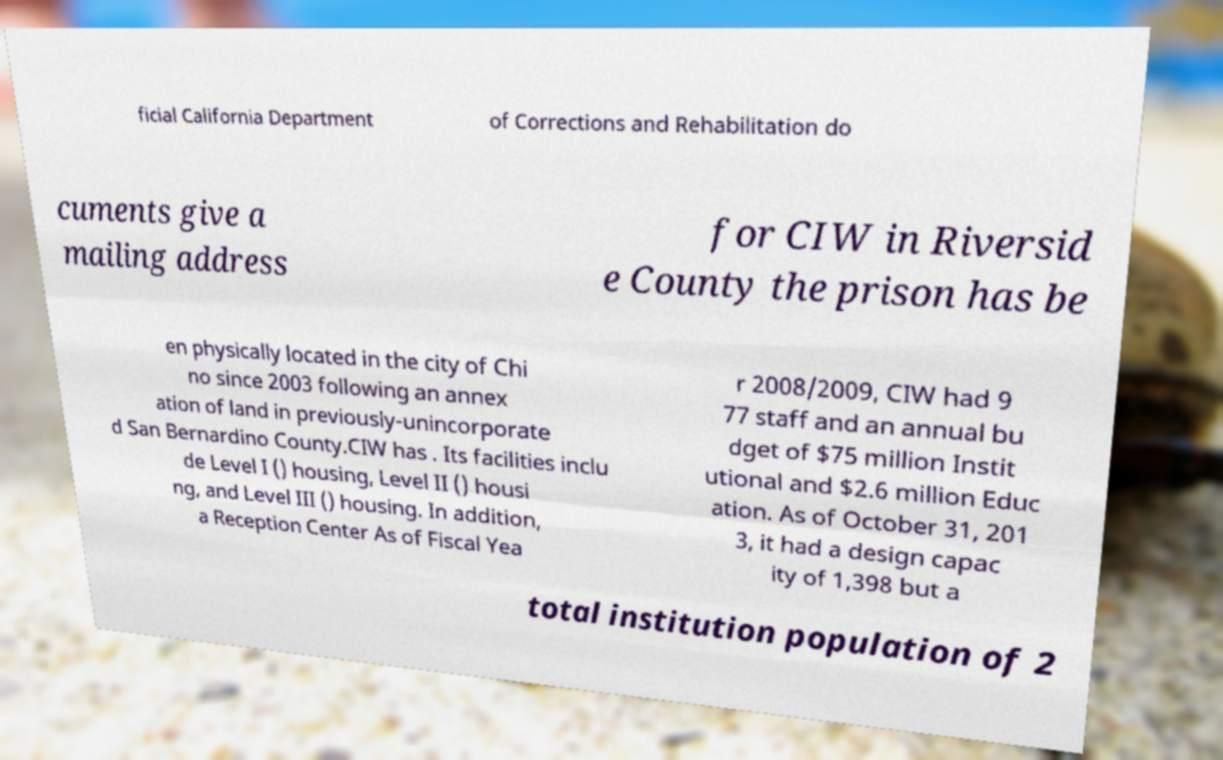There's text embedded in this image that I need extracted. Can you transcribe it verbatim? ficial California Department of Corrections and Rehabilitation do cuments give a mailing address for CIW in Riversid e County the prison has be en physically located in the city of Chi no since 2003 following an annex ation of land in previously-unincorporate d San Bernardino County.CIW has . Its facilities inclu de Level I () housing, Level II () housi ng, and Level III () housing. In addition, a Reception Center As of Fiscal Yea r 2008/2009, CIW had 9 77 staff and an annual bu dget of $75 million Instit utional and $2.6 million Educ ation. As of October 31, 201 3, it had a design capac ity of 1,398 but a total institution population of 2 